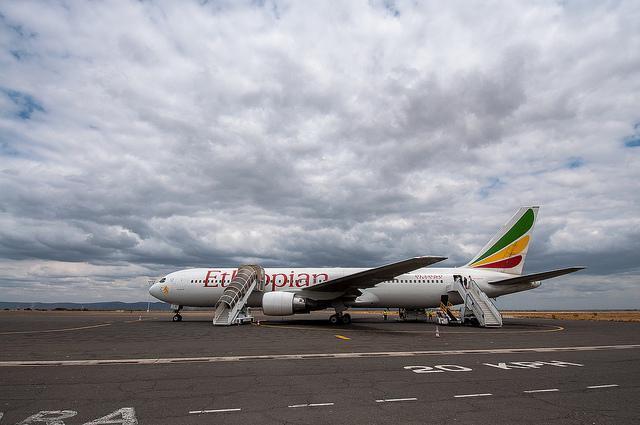How many planes are here?
Give a very brief answer. 1. 